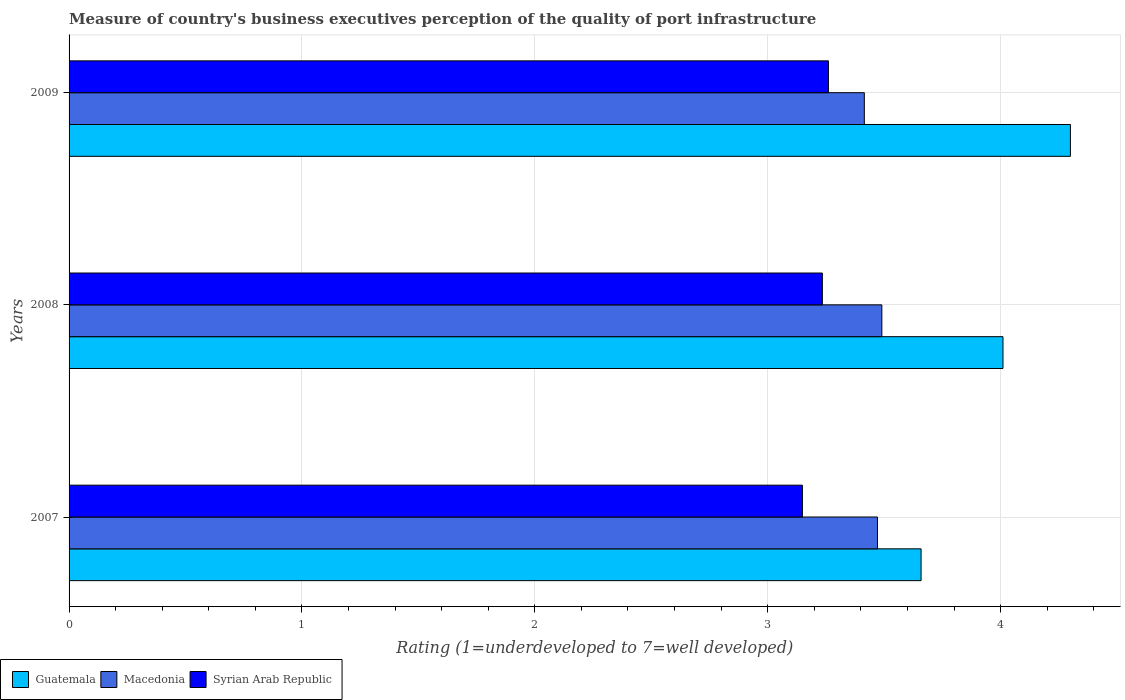How many different coloured bars are there?
Provide a short and direct response. 3. How many groups of bars are there?
Your answer should be compact. 3. How many bars are there on the 3rd tick from the top?
Provide a succinct answer. 3. In how many cases, is the number of bars for a given year not equal to the number of legend labels?
Offer a very short reply. 0. What is the ratings of the quality of port infrastructure in Guatemala in 2009?
Your answer should be compact. 4.3. Across all years, what is the maximum ratings of the quality of port infrastructure in Macedonia?
Offer a terse response. 3.49. Across all years, what is the minimum ratings of the quality of port infrastructure in Syrian Arab Republic?
Make the answer very short. 3.15. In which year was the ratings of the quality of port infrastructure in Macedonia minimum?
Keep it short and to the point. 2009. What is the total ratings of the quality of port infrastructure in Guatemala in the graph?
Make the answer very short. 11.97. What is the difference between the ratings of the quality of port infrastructure in Syrian Arab Republic in 2007 and that in 2009?
Keep it short and to the point. -0.11. What is the difference between the ratings of the quality of port infrastructure in Guatemala in 2009 and the ratings of the quality of port infrastructure in Macedonia in 2007?
Provide a short and direct response. 0.83. What is the average ratings of the quality of port infrastructure in Syrian Arab Republic per year?
Your answer should be very brief. 3.21. In the year 2009, what is the difference between the ratings of the quality of port infrastructure in Guatemala and ratings of the quality of port infrastructure in Macedonia?
Make the answer very short. 0.89. In how many years, is the ratings of the quality of port infrastructure in Syrian Arab Republic greater than 4.2 ?
Give a very brief answer. 0. What is the ratio of the ratings of the quality of port infrastructure in Syrian Arab Republic in 2008 to that in 2009?
Give a very brief answer. 0.99. What is the difference between the highest and the second highest ratings of the quality of port infrastructure in Macedonia?
Offer a terse response. 0.02. What is the difference between the highest and the lowest ratings of the quality of port infrastructure in Syrian Arab Republic?
Give a very brief answer. 0.11. Is the sum of the ratings of the quality of port infrastructure in Macedonia in 2007 and 2008 greater than the maximum ratings of the quality of port infrastructure in Syrian Arab Republic across all years?
Make the answer very short. Yes. What does the 1st bar from the top in 2008 represents?
Ensure brevity in your answer.  Syrian Arab Republic. What does the 1st bar from the bottom in 2008 represents?
Make the answer very short. Guatemala. How many bars are there?
Your answer should be compact. 9. What is the difference between two consecutive major ticks on the X-axis?
Keep it short and to the point. 1. Does the graph contain grids?
Your answer should be compact. Yes. Where does the legend appear in the graph?
Make the answer very short. Bottom left. How are the legend labels stacked?
Provide a succinct answer. Horizontal. What is the title of the graph?
Keep it short and to the point. Measure of country's business executives perception of the quality of port infrastructure. Does "Portugal" appear as one of the legend labels in the graph?
Keep it short and to the point. No. What is the label or title of the X-axis?
Make the answer very short. Rating (1=underdeveloped to 7=well developed). What is the Rating (1=underdeveloped to 7=well developed) in Guatemala in 2007?
Offer a very short reply. 3.66. What is the Rating (1=underdeveloped to 7=well developed) in Macedonia in 2007?
Give a very brief answer. 3.47. What is the Rating (1=underdeveloped to 7=well developed) of Syrian Arab Republic in 2007?
Give a very brief answer. 3.15. What is the Rating (1=underdeveloped to 7=well developed) in Guatemala in 2008?
Provide a short and direct response. 4.01. What is the Rating (1=underdeveloped to 7=well developed) in Macedonia in 2008?
Your response must be concise. 3.49. What is the Rating (1=underdeveloped to 7=well developed) of Syrian Arab Republic in 2008?
Your answer should be compact. 3.23. What is the Rating (1=underdeveloped to 7=well developed) of Guatemala in 2009?
Make the answer very short. 4.3. What is the Rating (1=underdeveloped to 7=well developed) of Macedonia in 2009?
Provide a succinct answer. 3.41. What is the Rating (1=underdeveloped to 7=well developed) of Syrian Arab Republic in 2009?
Your answer should be very brief. 3.26. Across all years, what is the maximum Rating (1=underdeveloped to 7=well developed) in Guatemala?
Provide a succinct answer. 4.3. Across all years, what is the maximum Rating (1=underdeveloped to 7=well developed) in Macedonia?
Your answer should be very brief. 3.49. Across all years, what is the maximum Rating (1=underdeveloped to 7=well developed) in Syrian Arab Republic?
Your answer should be very brief. 3.26. Across all years, what is the minimum Rating (1=underdeveloped to 7=well developed) in Guatemala?
Your response must be concise. 3.66. Across all years, what is the minimum Rating (1=underdeveloped to 7=well developed) in Macedonia?
Your answer should be very brief. 3.41. Across all years, what is the minimum Rating (1=underdeveloped to 7=well developed) of Syrian Arab Republic?
Offer a very short reply. 3.15. What is the total Rating (1=underdeveloped to 7=well developed) of Guatemala in the graph?
Ensure brevity in your answer.  11.97. What is the total Rating (1=underdeveloped to 7=well developed) in Macedonia in the graph?
Offer a very short reply. 10.38. What is the total Rating (1=underdeveloped to 7=well developed) in Syrian Arab Republic in the graph?
Provide a succinct answer. 9.64. What is the difference between the Rating (1=underdeveloped to 7=well developed) of Guatemala in 2007 and that in 2008?
Ensure brevity in your answer.  -0.35. What is the difference between the Rating (1=underdeveloped to 7=well developed) of Macedonia in 2007 and that in 2008?
Your answer should be compact. -0.02. What is the difference between the Rating (1=underdeveloped to 7=well developed) in Syrian Arab Republic in 2007 and that in 2008?
Provide a succinct answer. -0.09. What is the difference between the Rating (1=underdeveloped to 7=well developed) in Guatemala in 2007 and that in 2009?
Keep it short and to the point. -0.64. What is the difference between the Rating (1=underdeveloped to 7=well developed) of Macedonia in 2007 and that in 2009?
Give a very brief answer. 0.06. What is the difference between the Rating (1=underdeveloped to 7=well developed) in Syrian Arab Republic in 2007 and that in 2009?
Make the answer very short. -0.11. What is the difference between the Rating (1=underdeveloped to 7=well developed) in Guatemala in 2008 and that in 2009?
Ensure brevity in your answer.  -0.29. What is the difference between the Rating (1=underdeveloped to 7=well developed) of Macedonia in 2008 and that in 2009?
Your answer should be compact. 0.08. What is the difference between the Rating (1=underdeveloped to 7=well developed) in Syrian Arab Republic in 2008 and that in 2009?
Your answer should be compact. -0.03. What is the difference between the Rating (1=underdeveloped to 7=well developed) in Guatemala in 2007 and the Rating (1=underdeveloped to 7=well developed) in Macedonia in 2008?
Ensure brevity in your answer.  0.17. What is the difference between the Rating (1=underdeveloped to 7=well developed) in Guatemala in 2007 and the Rating (1=underdeveloped to 7=well developed) in Syrian Arab Republic in 2008?
Provide a short and direct response. 0.42. What is the difference between the Rating (1=underdeveloped to 7=well developed) of Macedonia in 2007 and the Rating (1=underdeveloped to 7=well developed) of Syrian Arab Republic in 2008?
Provide a short and direct response. 0.24. What is the difference between the Rating (1=underdeveloped to 7=well developed) in Guatemala in 2007 and the Rating (1=underdeveloped to 7=well developed) in Macedonia in 2009?
Your answer should be compact. 0.24. What is the difference between the Rating (1=underdeveloped to 7=well developed) of Guatemala in 2007 and the Rating (1=underdeveloped to 7=well developed) of Syrian Arab Republic in 2009?
Your response must be concise. 0.4. What is the difference between the Rating (1=underdeveloped to 7=well developed) of Macedonia in 2007 and the Rating (1=underdeveloped to 7=well developed) of Syrian Arab Republic in 2009?
Keep it short and to the point. 0.21. What is the difference between the Rating (1=underdeveloped to 7=well developed) of Guatemala in 2008 and the Rating (1=underdeveloped to 7=well developed) of Macedonia in 2009?
Keep it short and to the point. 0.6. What is the difference between the Rating (1=underdeveloped to 7=well developed) in Guatemala in 2008 and the Rating (1=underdeveloped to 7=well developed) in Syrian Arab Republic in 2009?
Provide a short and direct response. 0.75. What is the difference between the Rating (1=underdeveloped to 7=well developed) in Macedonia in 2008 and the Rating (1=underdeveloped to 7=well developed) in Syrian Arab Republic in 2009?
Offer a terse response. 0.23. What is the average Rating (1=underdeveloped to 7=well developed) in Guatemala per year?
Provide a succinct answer. 3.99. What is the average Rating (1=underdeveloped to 7=well developed) of Macedonia per year?
Ensure brevity in your answer.  3.46. What is the average Rating (1=underdeveloped to 7=well developed) of Syrian Arab Republic per year?
Provide a short and direct response. 3.21. In the year 2007, what is the difference between the Rating (1=underdeveloped to 7=well developed) of Guatemala and Rating (1=underdeveloped to 7=well developed) of Macedonia?
Your answer should be very brief. 0.19. In the year 2007, what is the difference between the Rating (1=underdeveloped to 7=well developed) in Guatemala and Rating (1=underdeveloped to 7=well developed) in Syrian Arab Republic?
Keep it short and to the point. 0.51. In the year 2007, what is the difference between the Rating (1=underdeveloped to 7=well developed) in Macedonia and Rating (1=underdeveloped to 7=well developed) in Syrian Arab Republic?
Offer a terse response. 0.32. In the year 2008, what is the difference between the Rating (1=underdeveloped to 7=well developed) in Guatemala and Rating (1=underdeveloped to 7=well developed) in Macedonia?
Your response must be concise. 0.52. In the year 2008, what is the difference between the Rating (1=underdeveloped to 7=well developed) in Guatemala and Rating (1=underdeveloped to 7=well developed) in Syrian Arab Republic?
Keep it short and to the point. 0.78. In the year 2008, what is the difference between the Rating (1=underdeveloped to 7=well developed) in Macedonia and Rating (1=underdeveloped to 7=well developed) in Syrian Arab Republic?
Give a very brief answer. 0.26. In the year 2009, what is the difference between the Rating (1=underdeveloped to 7=well developed) in Guatemala and Rating (1=underdeveloped to 7=well developed) in Macedonia?
Give a very brief answer. 0.89. In the year 2009, what is the difference between the Rating (1=underdeveloped to 7=well developed) in Guatemala and Rating (1=underdeveloped to 7=well developed) in Syrian Arab Republic?
Your answer should be very brief. 1.04. In the year 2009, what is the difference between the Rating (1=underdeveloped to 7=well developed) in Macedonia and Rating (1=underdeveloped to 7=well developed) in Syrian Arab Republic?
Make the answer very short. 0.15. What is the ratio of the Rating (1=underdeveloped to 7=well developed) in Guatemala in 2007 to that in 2008?
Provide a short and direct response. 0.91. What is the ratio of the Rating (1=underdeveloped to 7=well developed) in Macedonia in 2007 to that in 2008?
Your answer should be compact. 0.99. What is the ratio of the Rating (1=underdeveloped to 7=well developed) of Syrian Arab Republic in 2007 to that in 2008?
Offer a terse response. 0.97. What is the ratio of the Rating (1=underdeveloped to 7=well developed) of Guatemala in 2007 to that in 2009?
Your response must be concise. 0.85. What is the ratio of the Rating (1=underdeveloped to 7=well developed) in Macedonia in 2007 to that in 2009?
Offer a terse response. 1.02. What is the ratio of the Rating (1=underdeveloped to 7=well developed) of Syrian Arab Republic in 2007 to that in 2009?
Give a very brief answer. 0.97. What is the ratio of the Rating (1=underdeveloped to 7=well developed) in Guatemala in 2008 to that in 2009?
Make the answer very short. 0.93. What is the ratio of the Rating (1=underdeveloped to 7=well developed) in Macedonia in 2008 to that in 2009?
Keep it short and to the point. 1.02. What is the ratio of the Rating (1=underdeveloped to 7=well developed) of Syrian Arab Republic in 2008 to that in 2009?
Ensure brevity in your answer.  0.99. What is the difference between the highest and the second highest Rating (1=underdeveloped to 7=well developed) of Guatemala?
Your answer should be very brief. 0.29. What is the difference between the highest and the second highest Rating (1=underdeveloped to 7=well developed) of Macedonia?
Give a very brief answer. 0.02. What is the difference between the highest and the second highest Rating (1=underdeveloped to 7=well developed) in Syrian Arab Republic?
Your answer should be compact. 0.03. What is the difference between the highest and the lowest Rating (1=underdeveloped to 7=well developed) in Guatemala?
Ensure brevity in your answer.  0.64. What is the difference between the highest and the lowest Rating (1=underdeveloped to 7=well developed) in Macedonia?
Your answer should be very brief. 0.08. What is the difference between the highest and the lowest Rating (1=underdeveloped to 7=well developed) of Syrian Arab Republic?
Provide a short and direct response. 0.11. 